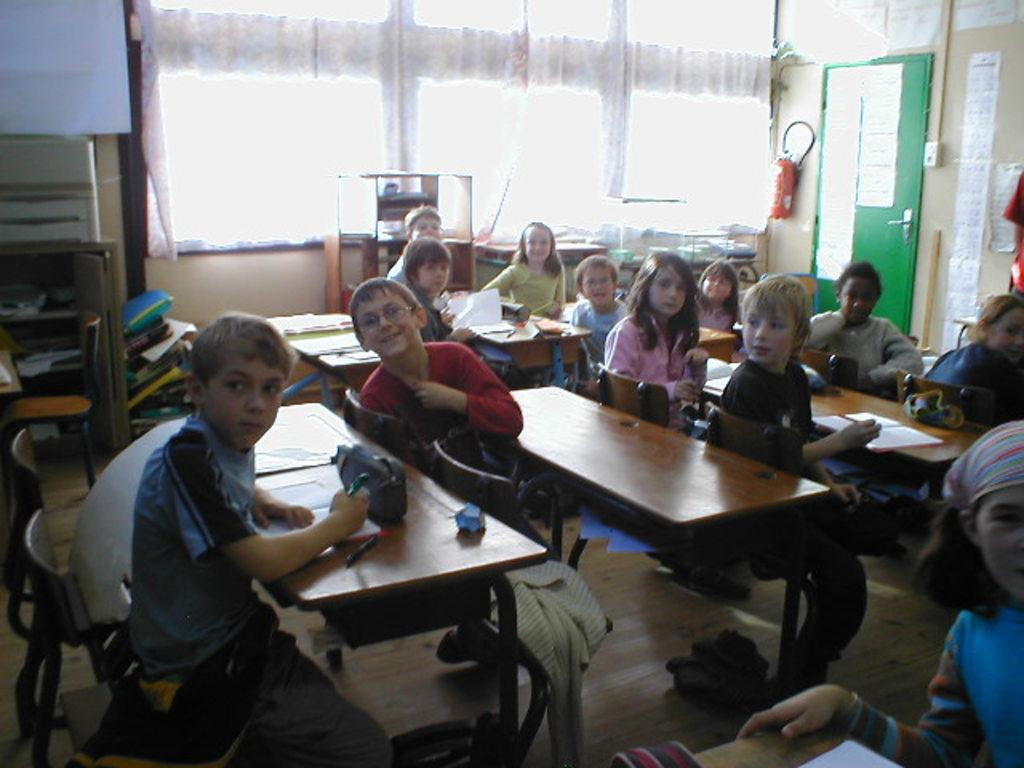Who is present in the image? There are children in the image. What are the children doing in the image? The children are sitting on benches. What else can be seen in the image besides the children? There are books visible in the image. What type of rabbit can be seen reading a fiction book in the image? There is no rabbit or fiction book present in the image; it features children sitting on benches with books. What material is the brass used for in the image? There is no brass present in the image. 